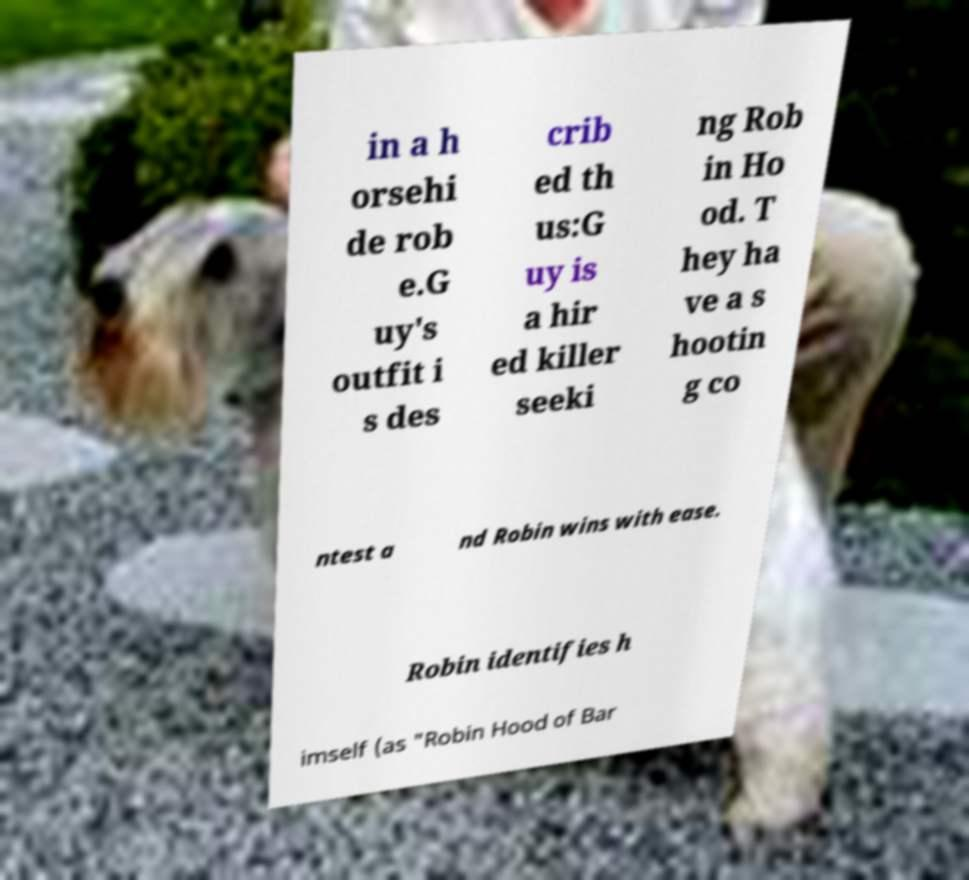Please read and relay the text visible in this image. What does it say? in a h orsehi de rob e.G uy's outfit i s des crib ed th us:G uy is a hir ed killer seeki ng Rob in Ho od. T hey ha ve a s hootin g co ntest a nd Robin wins with ease. Robin identifies h imself (as "Robin Hood of Bar 